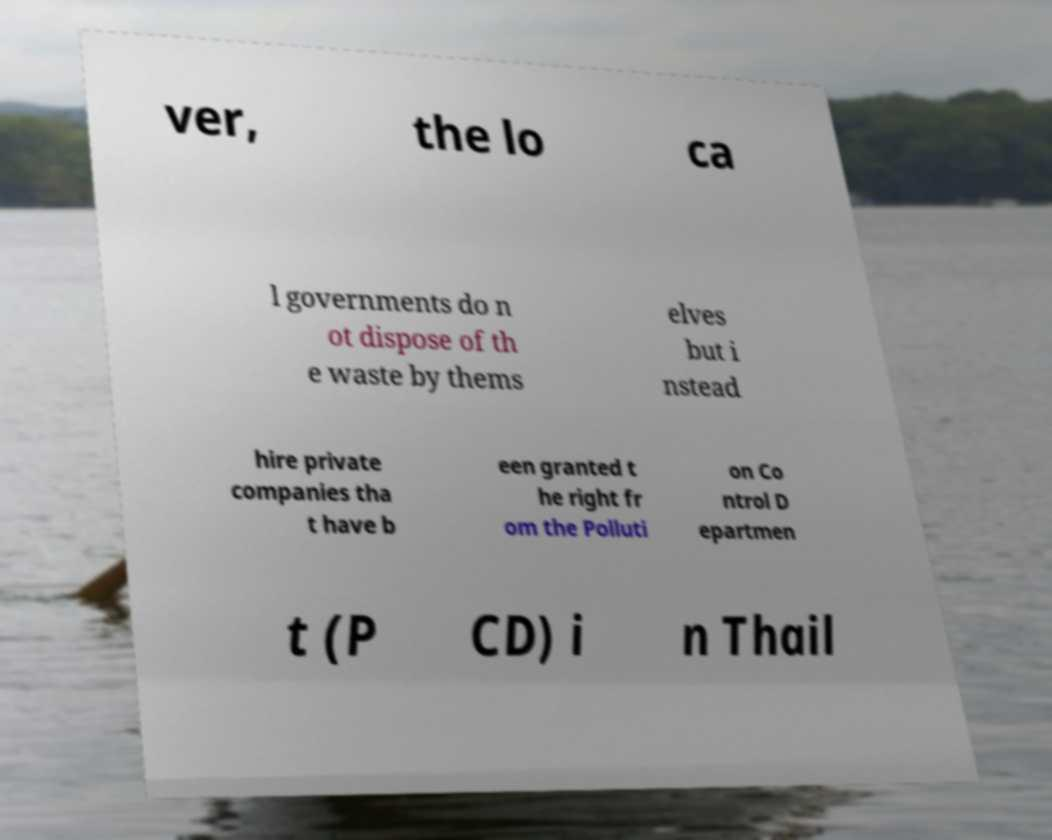Can you accurately transcribe the text from the provided image for me? ver, the lo ca l governments do n ot dispose of th e waste by thems elves but i nstead hire private companies tha t have b een granted t he right fr om the Polluti on Co ntrol D epartmen t (P CD) i n Thail 